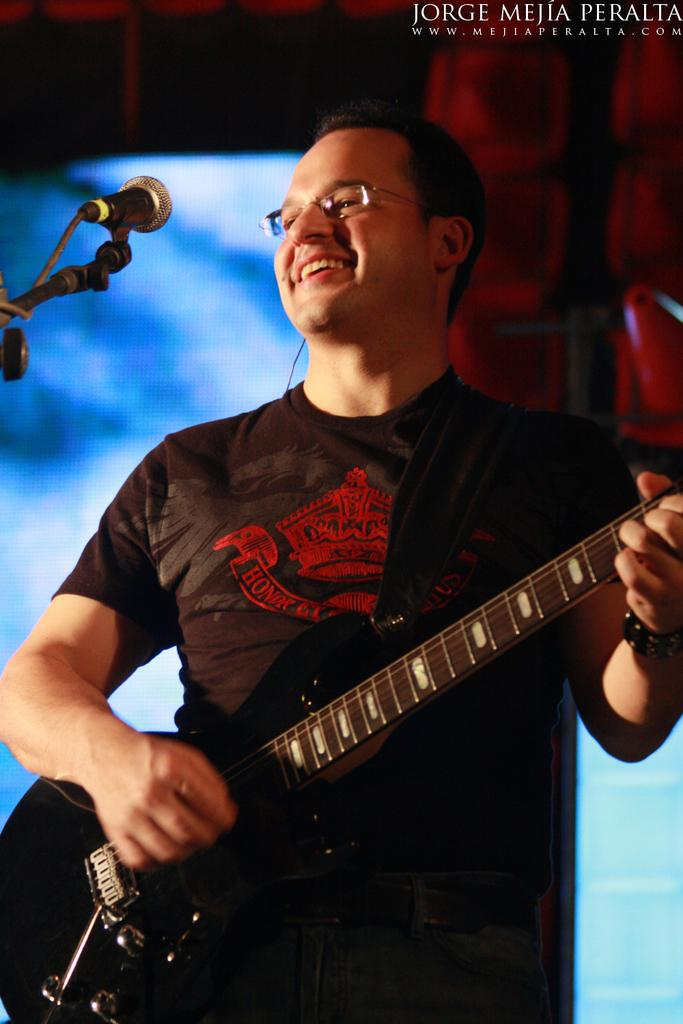What is the person in the image doing? The person is playing a guitar. What expression does the person have? The person is smiling. What object is in front of the person? There is a microphone present in front of the person. What color is the background of the image? The background of the image is blue. What type of spoon is being used to play the guitar in the image? There is no spoon present in the image, and the person is playing the guitar with their hands. What type of flag is being waved in the background of the image? There is no flag present in the image; the background is blue. 